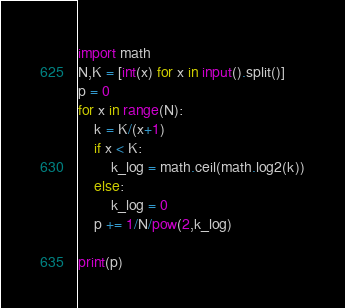Convert code to text. <code><loc_0><loc_0><loc_500><loc_500><_Python_>import math
N,K = [int(x) for x in input().split()]
p = 0
for x in range(N):
    k = K/(x+1)
    if x < K:
        k_log = math.ceil(math.log2(k))
    else:
        k_log = 0
    p += 1/N/pow(2,k_log)

print(p)</code> 